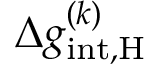Convert formula to latex. <formula><loc_0><loc_0><loc_500><loc_500>\Delta g _ { i n t , \mathrm { H } } ^ { ( k ) }</formula> 